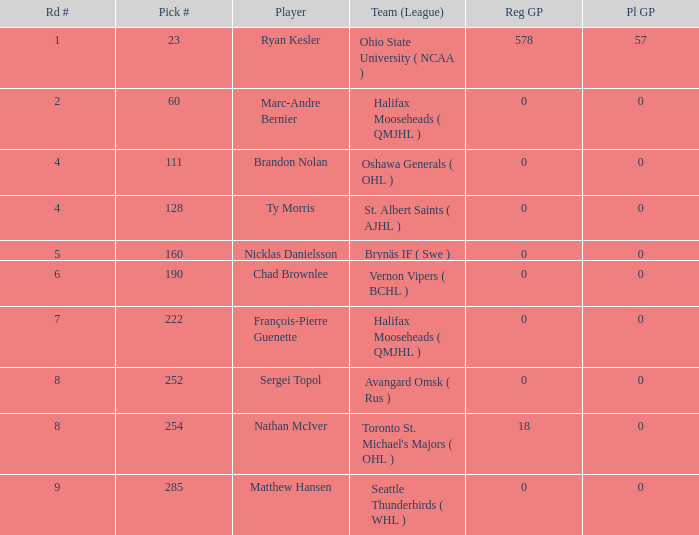What's the highest Pl GP with a Reg GP over 18? 57.0. Can you parse all the data within this table? {'header': ['Rd #', 'Pick #', 'Player', 'Team (League)', 'Reg GP', 'Pl GP'], 'rows': [['1', '23', 'Ryan Kesler', 'Ohio State University ( NCAA )', '578', '57'], ['2', '60', 'Marc-Andre Bernier', 'Halifax Mooseheads ( QMJHL )', '0', '0'], ['4', '111', 'Brandon Nolan', 'Oshawa Generals ( OHL )', '0', '0'], ['4', '128', 'Ty Morris', 'St. Albert Saints ( AJHL )', '0', '0'], ['5', '160', 'Nicklas Danielsson', 'Brynäs IF ( Swe )', '0', '0'], ['6', '190', 'Chad Brownlee', 'Vernon Vipers ( BCHL )', '0', '0'], ['7', '222', 'François-Pierre Guenette', 'Halifax Mooseheads ( QMJHL )', '0', '0'], ['8', '252', 'Sergei Topol', 'Avangard Omsk ( Rus )', '0', '0'], ['8', '254', 'Nathan McIver', "Toronto St. Michael's Majors ( OHL )", '18', '0'], ['9', '285', 'Matthew Hansen', 'Seattle Thunderbirds ( WHL )', '0', '0']]} 